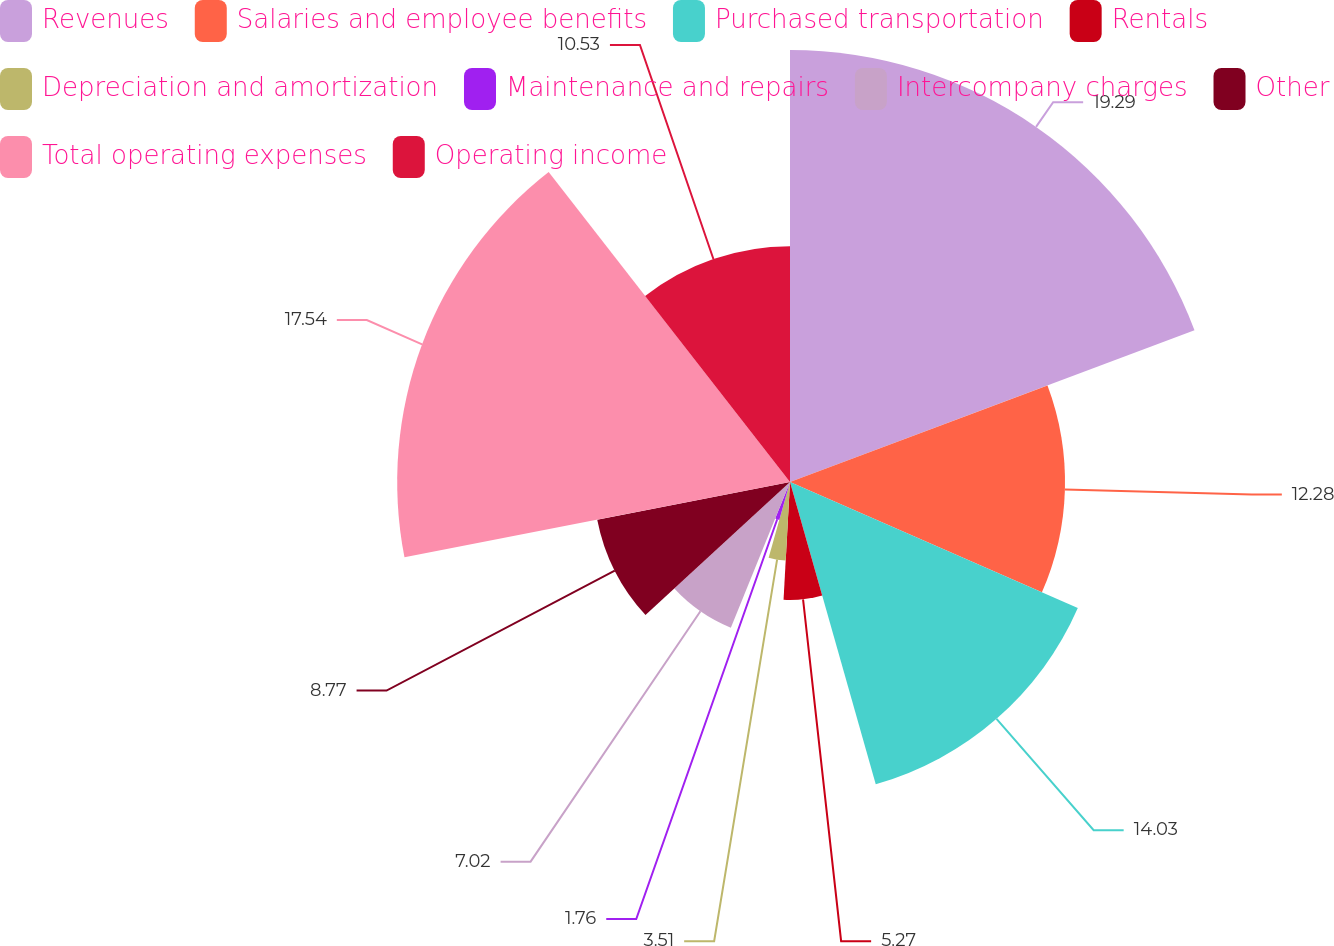Convert chart to OTSL. <chart><loc_0><loc_0><loc_500><loc_500><pie_chart><fcel>Revenues<fcel>Salaries and employee benefits<fcel>Purchased transportation<fcel>Rentals<fcel>Depreciation and amortization<fcel>Maintenance and repairs<fcel>Intercompany charges<fcel>Other<fcel>Total operating expenses<fcel>Operating income<nl><fcel>19.29%<fcel>12.28%<fcel>14.03%<fcel>5.27%<fcel>3.51%<fcel>1.76%<fcel>7.02%<fcel>8.77%<fcel>17.54%<fcel>10.53%<nl></chart> 